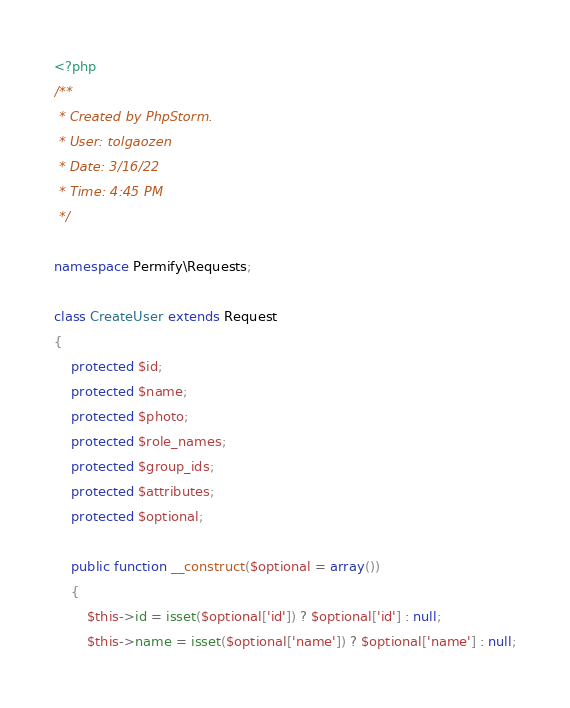<code> <loc_0><loc_0><loc_500><loc_500><_PHP_><?php
/**
 * Created by PhpStorm.
 * User: tolgaozen
 * Date: 3/16/22
 * Time: 4:45 PM
 */

namespace Permify\Requests;

class CreateUser extends Request
{
    protected $id;
    protected $name;
    protected $photo;
    protected $role_names;
    protected $group_ids;
    protected $attributes;
    protected $optional;

    public function __construct($optional = array())
    {
        $this->id = isset($optional['id']) ? $optional['id'] : null;
        $this->name = isset($optional['name']) ? $optional['name'] : null;</code> 